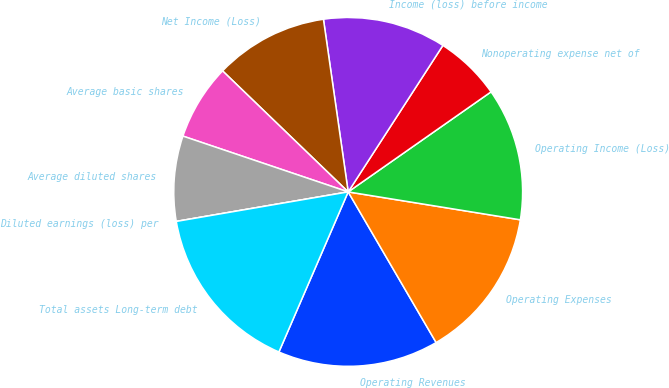Convert chart to OTSL. <chart><loc_0><loc_0><loc_500><loc_500><pie_chart><fcel>Operating Revenues<fcel>Operating Expenses<fcel>Operating Income (Loss)<fcel>Nonoperating expense net of<fcel>Income (loss) before income<fcel>Net Income (Loss)<fcel>Average basic shares<fcel>Average diluted shares<fcel>Diluted earnings (loss) per<fcel>Total assets Long-term debt<nl><fcel>14.91%<fcel>14.03%<fcel>12.28%<fcel>6.14%<fcel>11.4%<fcel>10.53%<fcel>7.02%<fcel>7.89%<fcel>0.0%<fcel>15.79%<nl></chart> 